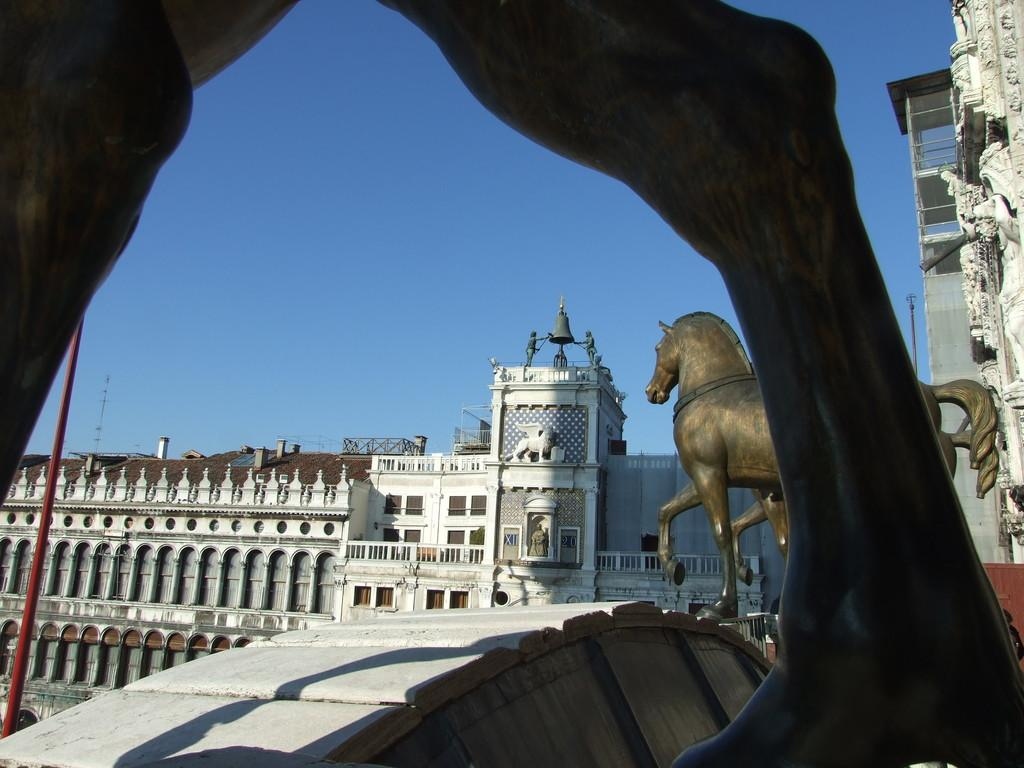What objects are present in the image? There are statues in the image. What can be seen in the background of the image? There are buildings and poles in the background of the image. What type of jeans is the friend wearing in the image? There is no reference to jeans, friends, or a band in the image, so it is not possible to answer that question. 